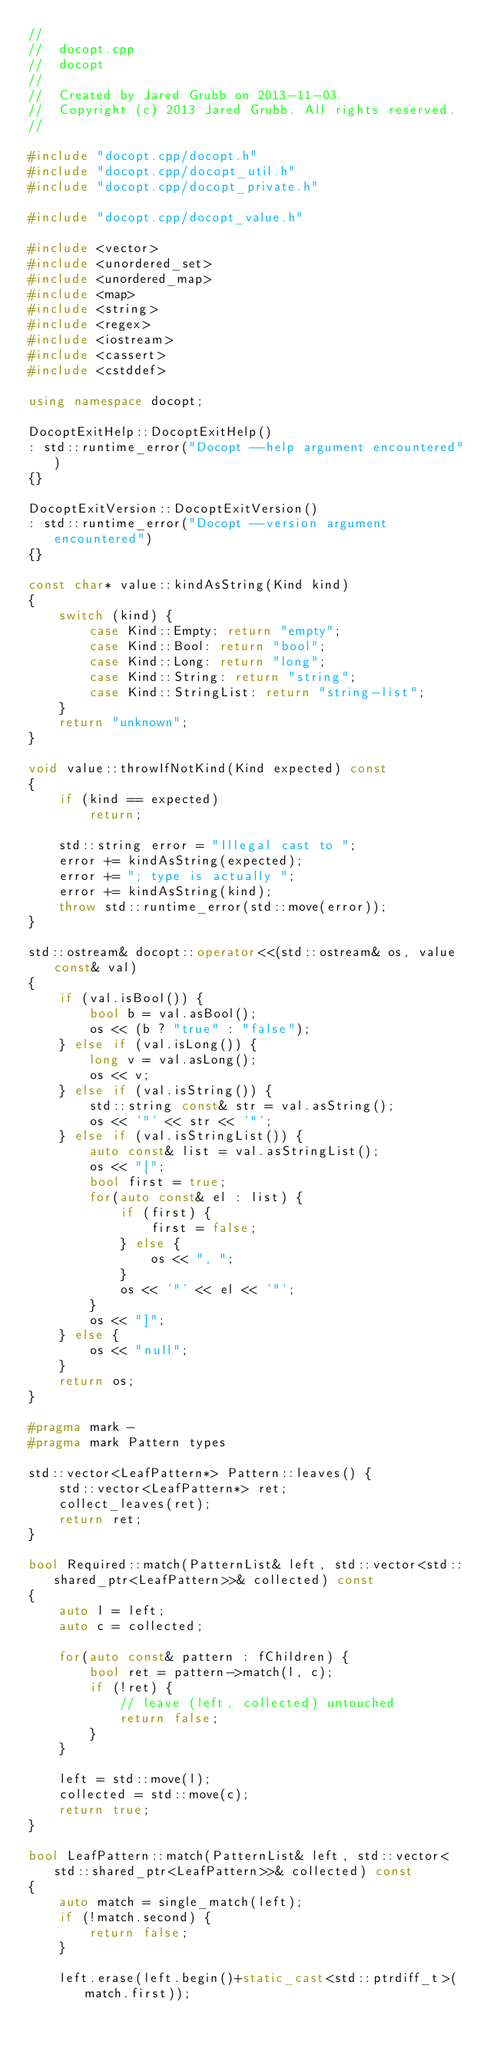<code> <loc_0><loc_0><loc_500><loc_500><_C++_>//
//  docopt.cpp
//  docopt
//
//  Created by Jared Grubb on 2013-11-03.
//  Copyright (c) 2013 Jared Grubb. All rights reserved.
//

#include "docopt.cpp/docopt.h"
#include "docopt.cpp/docopt_util.h"
#include "docopt.cpp/docopt_private.h"

#include "docopt.cpp/docopt_value.h"

#include <vector>
#include <unordered_set>
#include <unordered_map>
#include <map>
#include <string>
#include <regex>
#include <iostream>
#include <cassert>
#include <cstddef>

using namespace docopt;

DocoptExitHelp::DocoptExitHelp()
: std::runtime_error("Docopt --help argument encountered")
{}

DocoptExitVersion::DocoptExitVersion()
: std::runtime_error("Docopt --version argument encountered")
{}

const char* value::kindAsString(Kind kind)
{
	switch (kind) {
		case Kind::Empty: return "empty";
		case Kind::Bool: return "bool";
		case Kind::Long: return "long";
		case Kind::String: return "string";
		case Kind::StringList: return "string-list";
	}
	return "unknown";
}

void value::throwIfNotKind(Kind expected) const
{
	if (kind == expected)
		return;

	std::string error = "Illegal cast to ";
	error += kindAsString(expected);
	error += "; type is actually ";
	error += kindAsString(kind);
	throw std::runtime_error(std::move(error));
}

std::ostream& docopt::operator<<(std::ostream& os, value const& val)
{
	if (val.isBool()) {
		bool b = val.asBool();
		os << (b ? "true" : "false");
	} else if (val.isLong()) {
		long v = val.asLong();
		os << v;
	} else if (val.isString()) {
		std::string const& str = val.asString();
		os << '"' << str << '"';
	} else if (val.isStringList()) {
		auto const& list = val.asStringList();
		os << "[";
		bool first = true;
		for(auto const& el : list) {
			if (first) {
				first = false;
			} else {
				os << ", ";
			}
			os << '"' << el << '"';
		}
		os << "]";
	} else {
		os << "null";
	}
	return os;
}

#pragma mark -
#pragma mark Pattern types

std::vector<LeafPattern*> Pattern::leaves() {
	std::vector<LeafPattern*> ret;
	collect_leaves(ret);
	return ret;
}

bool Required::match(PatternList& left, std::vector<std::shared_ptr<LeafPattern>>& collected) const
{
	auto l = left;
	auto c = collected;

	for(auto const& pattern : fChildren) {
		bool ret = pattern->match(l, c);
		if (!ret) {
			// leave (left, collected) untouched
			return false;
		}
	}

	left = std::move(l);
	collected = std::move(c);
	return true;
}

bool LeafPattern::match(PatternList& left, std::vector<std::shared_ptr<LeafPattern>>& collected) const
{
	auto match = single_match(left);
	if (!match.second) {
		return false;
	}

	left.erase(left.begin()+static_cast<std::ptrdiff_t>(match.first));
</code> 